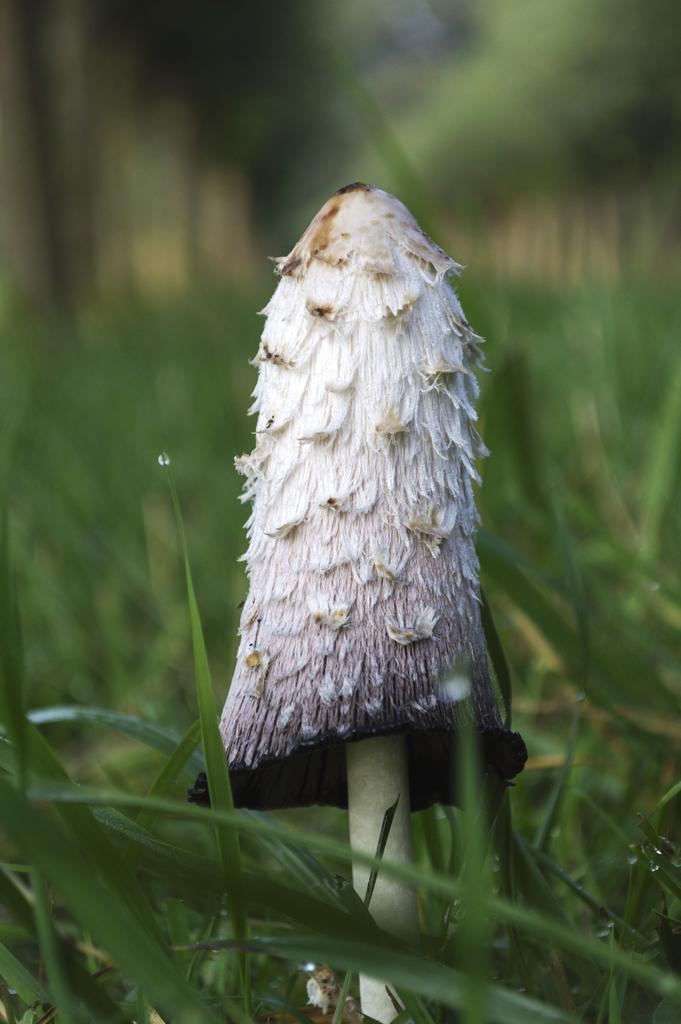Please provide a concise description of this image. In this image I can see the mushroom in white color and I can see the grass in green color. 